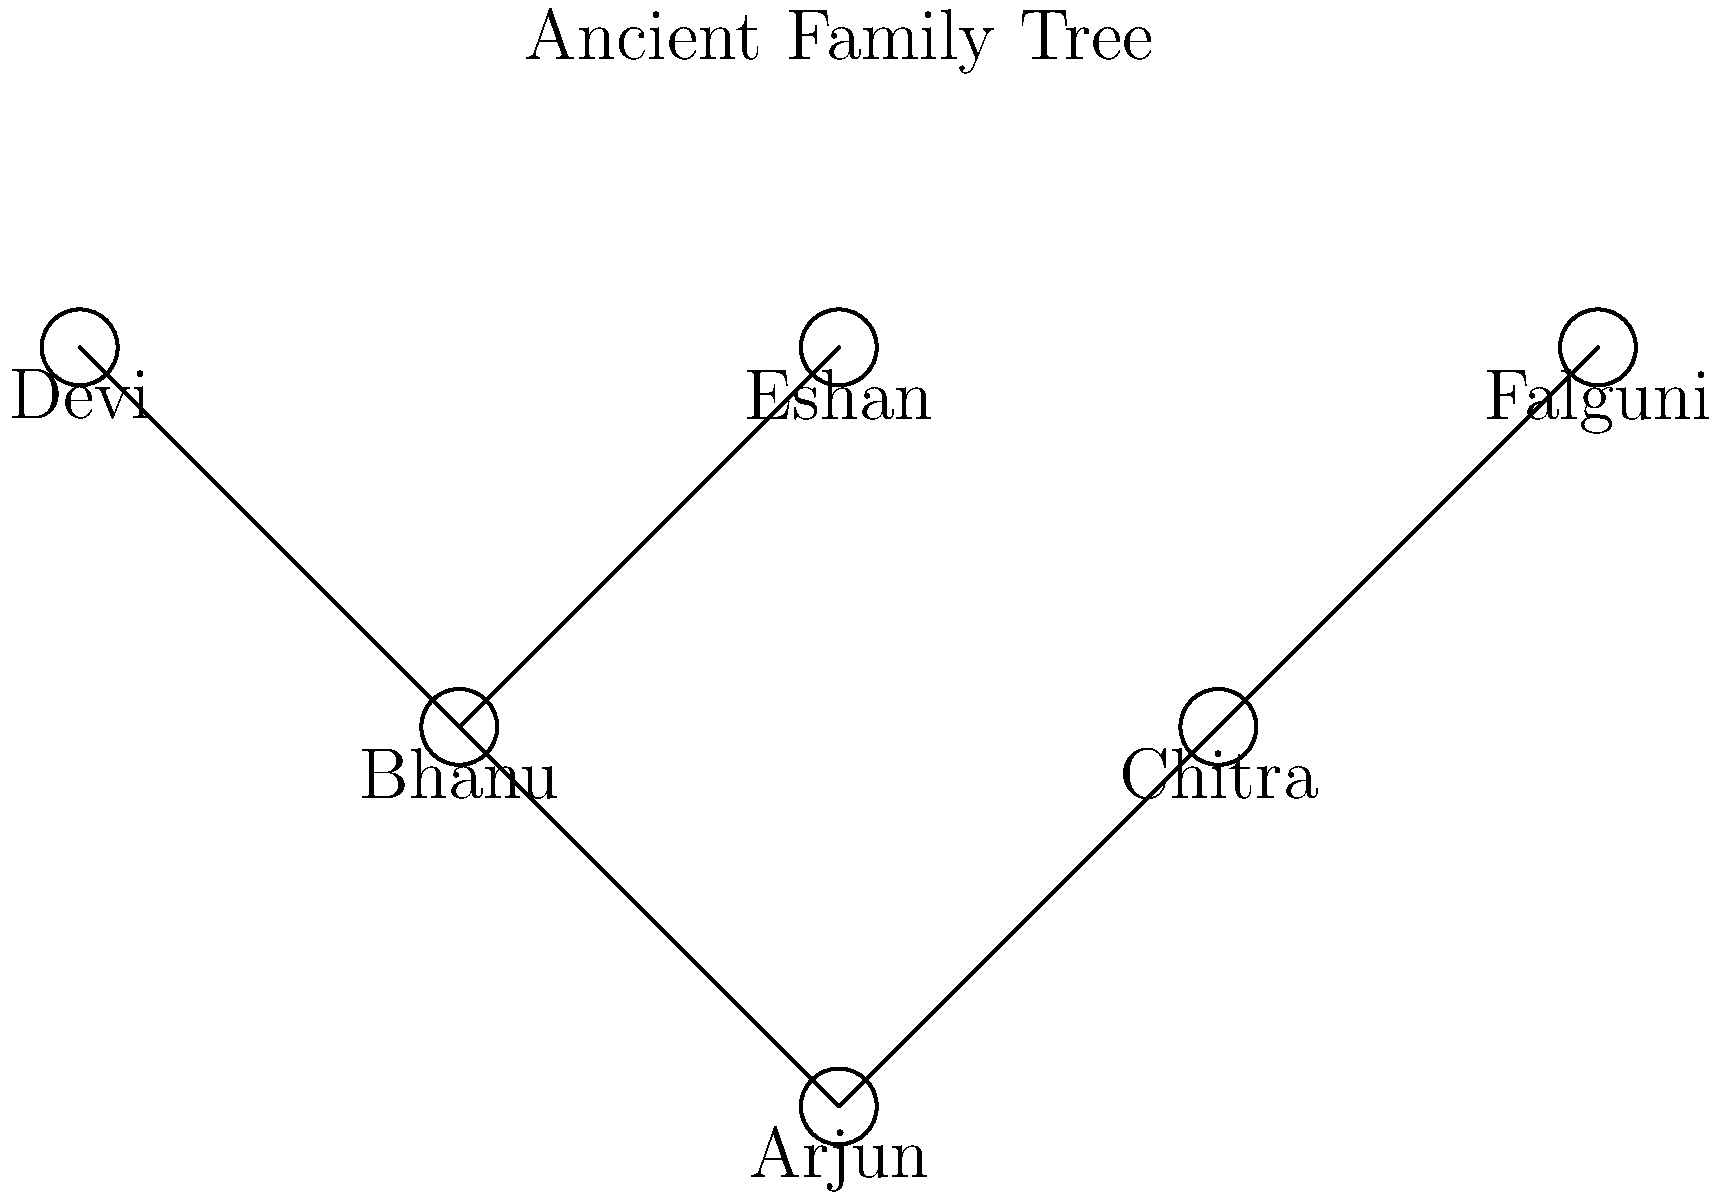In the ancient family tree chart shown above, who are the parents of Bhanu? To determine Bhanu's parents, we need to follow these steps:

1. Locate Bhanu on the family tree chart. Bhanu is positioned at the second level from the bottom, on the left side.

2. Identify the connections above Bhanu. We can see two lines extending upward from Bhanu's position.

3. These lines connect to two individuals on the level above: Devi and Eshan.

4. In a family tree, lines connecting from a lower level to an upper level indicate a parent-child relationship.

5. Therefore, the two individuals connected directly above Bhanu are Bhanu's parents.

6. We can conclude that Devi and Eshan are Bhanu's parents.

This interpretation is based on the standard convention of family tree charts, where individuals at higher levels represent older generations (parents, grandparents) and those at lower levels represent younger generations (children, grandchildren).
Answer: Devi and Eshan 